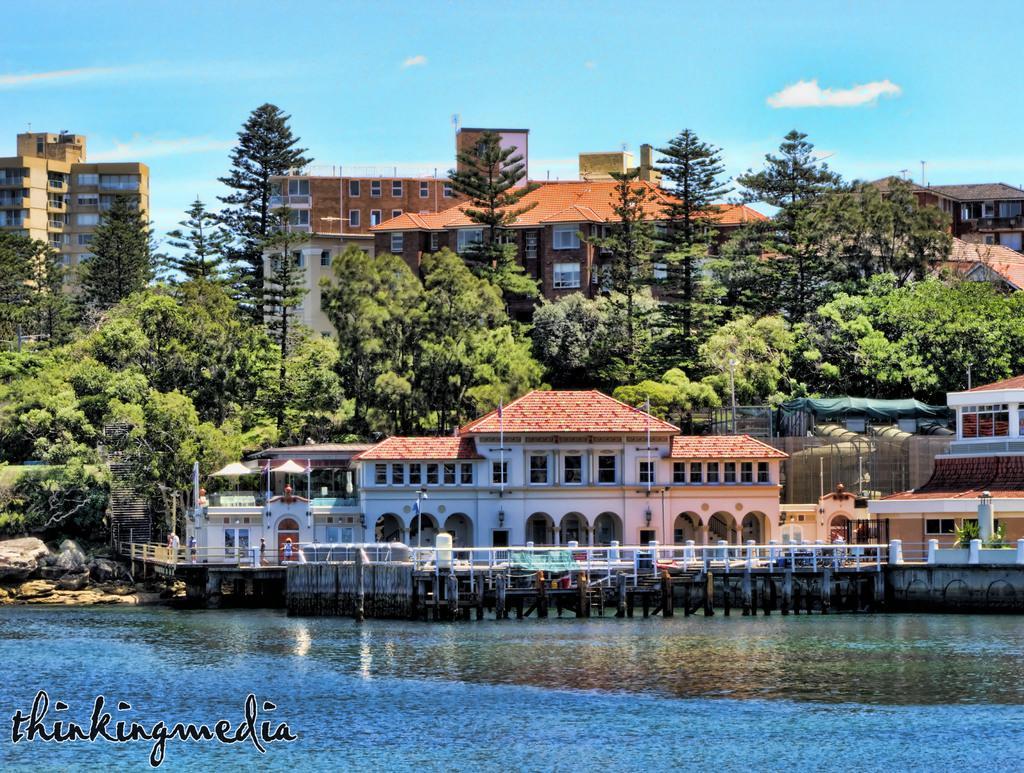Can you describe this image briefly? Here in this picture we can see buildings and houses present over a place and in the front we can see water present and on the ground we can see some rock stones, grass and plants and trees present and we can see clouds in the sky. 